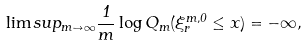<formula> <loc_0><loc_0><loc_500><loc_500>\lim s u p _ { m \to \infty } \frac { 1 } { m } \log Q _ { m } ( \xi _ { r } ^ { m , 0 } \leq x ) = - \infty ,</formula> 